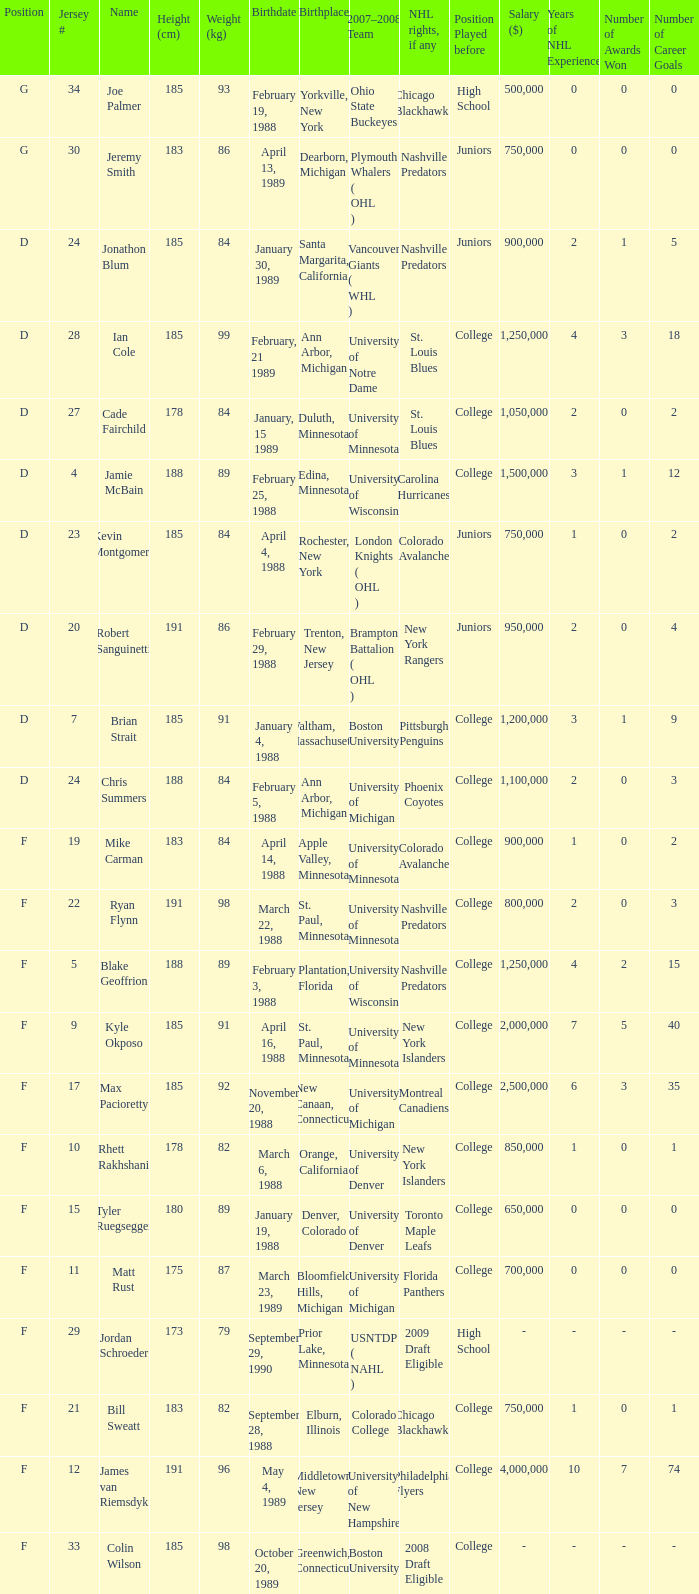Which Weight (kg) has a NHL rights, if any of phoenix coyotes? 1.0. 